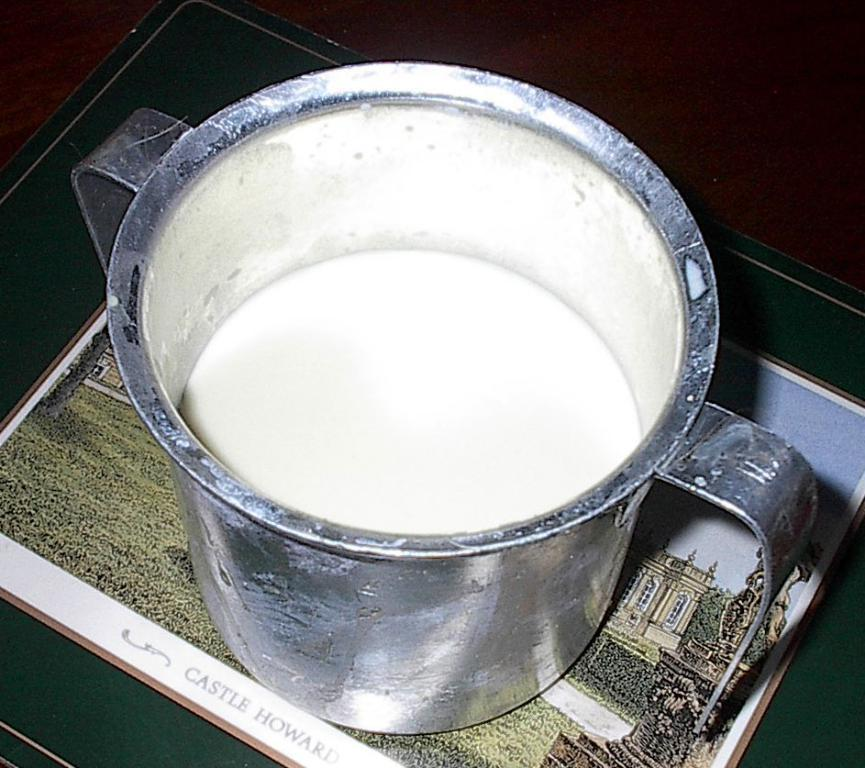What is depicted on the poster in the image? There is a jug on a poster in the image. What is inside the jug on the poster? The jug contains milk. Where is the poster located in the image? The poster is on a surface in the image. Can you see any lake, engine, or window in the image? No, there is no lake, engine, or window present in the image. 